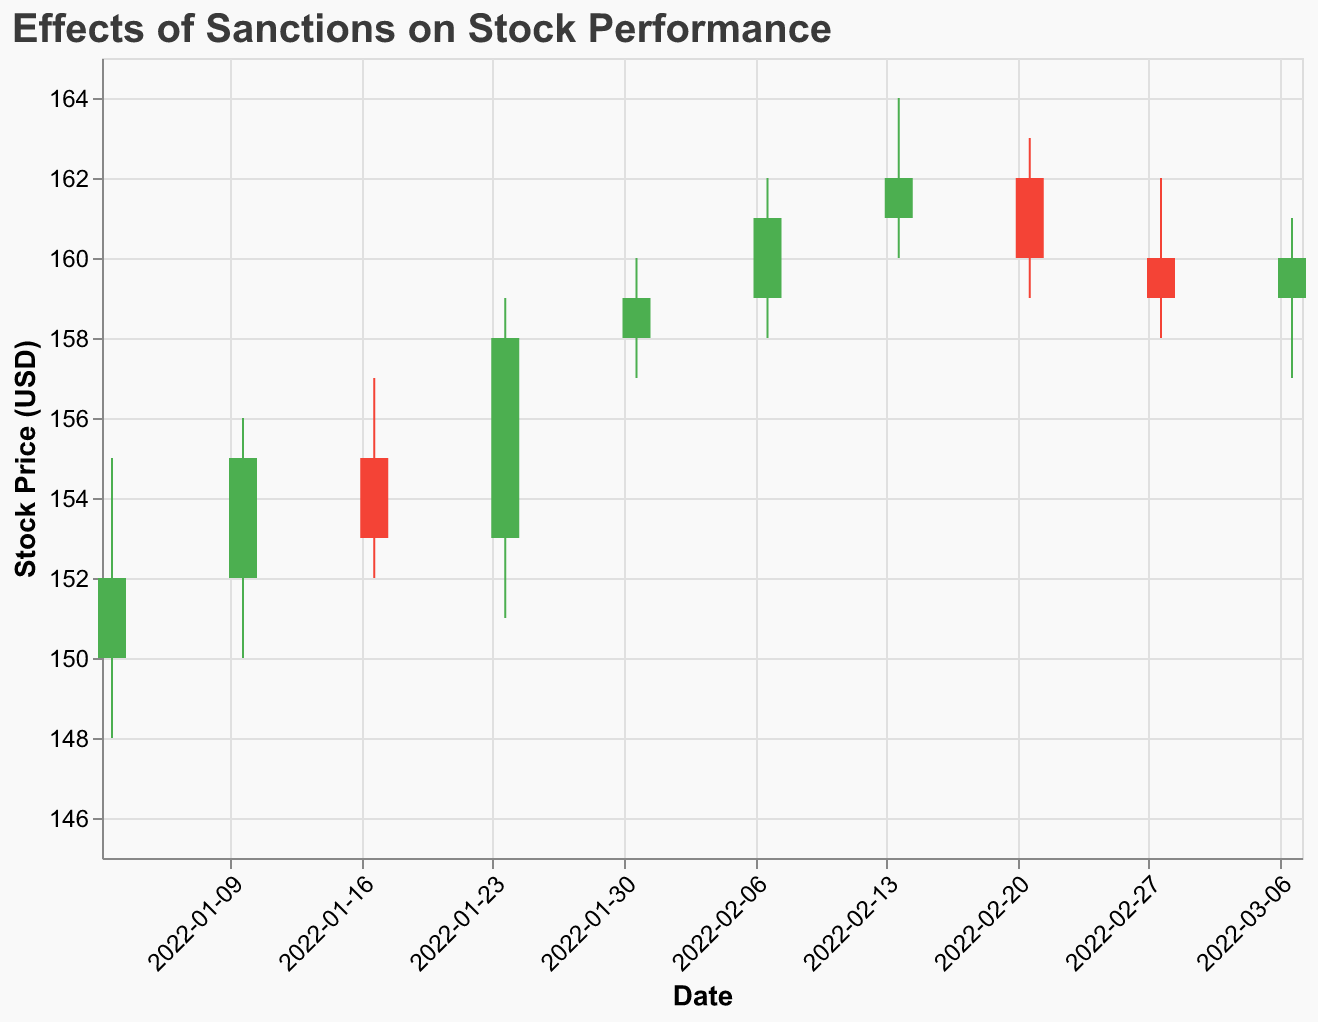How many data points are shown in the figure? Count the number of candlesticks on the plot, which represent the data points. The data covers dates from January 3, 2022, to March 7, 2022, at one-week intervals.
Answer: 10 What is the title of the plot? Look at the top of the plot where the title is displayed.
Answer: Effects of Sanctions on Stock Performance Which organization's stock had the highest closing price, and what was that price? Locate the highest position of the upper end of the candlesticks for the Close value, and then identify the corresponding organization. The highest Close value is 162 on February 14, associated with Caterpillar Inc.
Answer: Caterpillar Inc, 162 How did ExxonMobil's stock price change after the sanctions were imposed on Russia on January 3, 2022? Identify the data for January 3, noting the Open and Close values for ExxonMobil. The stock opened at 150 and closed at 152, indicating an increase.
Answer: Increased What is the average closing price for the organizations in January 2022? Calculate the sum of the closing prices for January (152, 155, 153, 158) and divide by the number of data points (4). (152 + 155 + 153 + 158) / 4 = 154.5
Answer: 154.5 Which organization experienced a drop in stock price after sanctions were discussed or imposed? Look for data points where the Close value is lower than the Open value, and identify the corresponding organization and event. For instance, on February 21, BMW's stock closed lower after the announcement of sanctions on Iran (Open: 162, Close: 160).
Answer: BMW On which date did Samsung experience the largest bullish move, and what was the price range for that date? Identify the candlestick with the longest green body (Open<Close) associated with Samsung. The largest bullish move for Samsung occurred on January 24, with prices ranging from a Low of 151 to a High of 159.
Answer: January 24, 151 to 159 How does the stock performance generally trend after sanctions are lifted or eased? Evaluate data points following events where sanctions were lifted or eased (January 10 for Coca-Cola and January 24 for Samsung). Both organizations experienced an increase in their closing prices.
Answer: Increase Which stock had the lowest opening price, and what was the opening price? Identify the lowest value on the y-axis under the "Open" column. The lowest opening price is 150, which occurred for ExxonMobil on January 3.
Answer: ExxonMobil, 150 How did the volume of traded stocks affect the closing prices in weeks with high volumes? Look at the volumes and the corresponding closing prices. High volumes are seen on February 14 (Caterpillar Inc., Volume: 2600000, Close: 162) and March 7 (Toyota, Volume: 2500000, Close: 160). Both have relatively high closing prices compared to some other dates.
Answer: Generally higher closing prices 